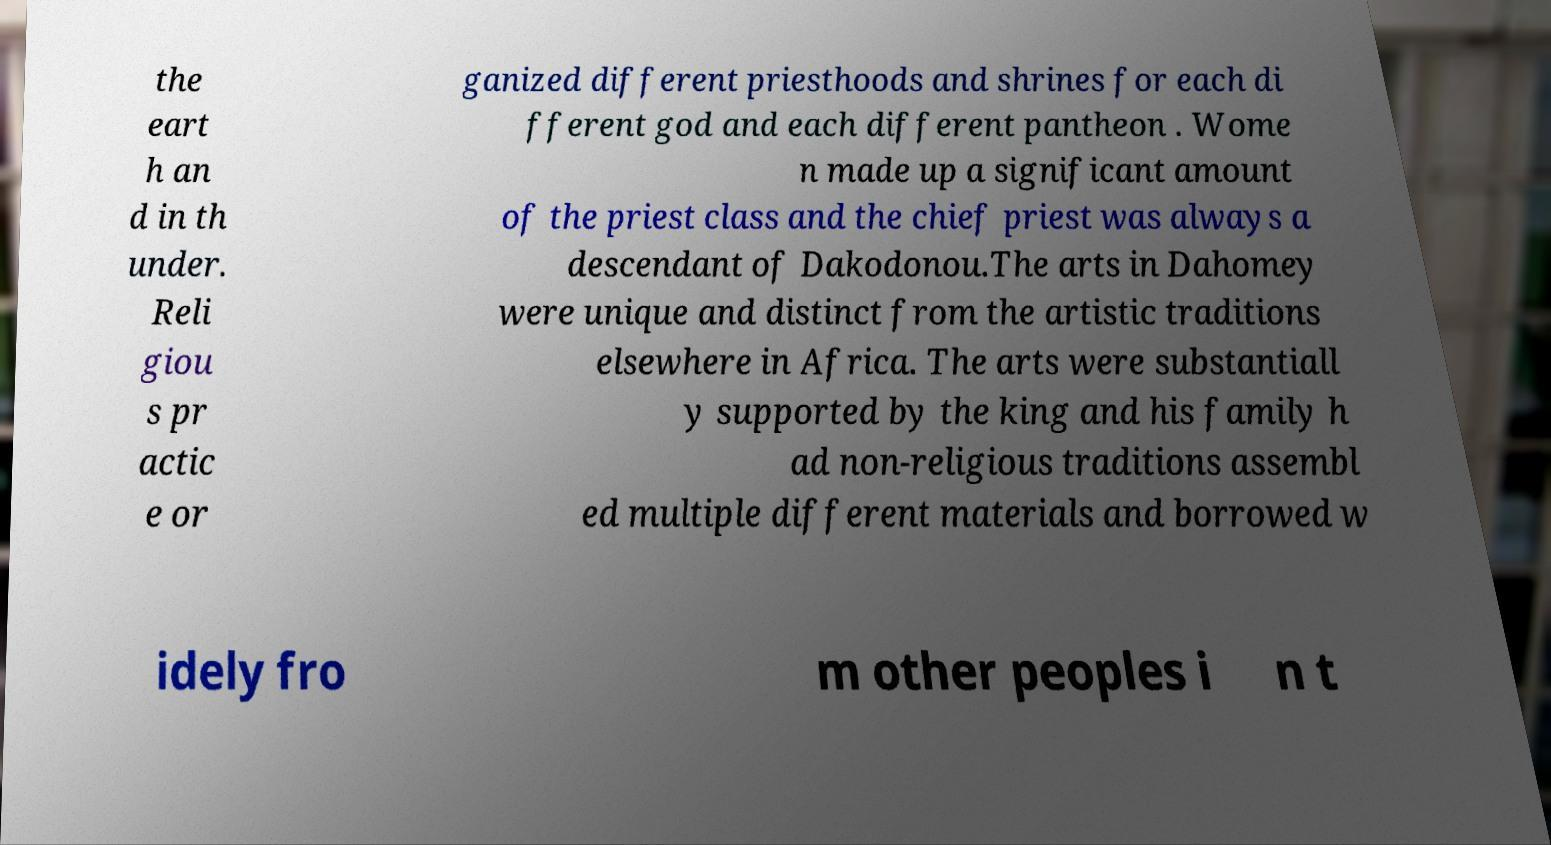There's text embedded in this image that I need extracted. Can you transcribe it verbatim? the eart h an d in th under. Reli giou s pr actic e or ganized different priesthoods and shrines for each di fferent god and each different pantheon . Wome n made up a significant amount of the priest class and the chief priest was always a descendant of Dakodonou.The arts in Dahomey were unique and distinct from the artistic traditions elsewhere in Africa. The arts were substantiall y supported by the king and his family h ad non-religious traditions assembl ed multiple different materials and borrowed w idely fro m other peoples i n t 